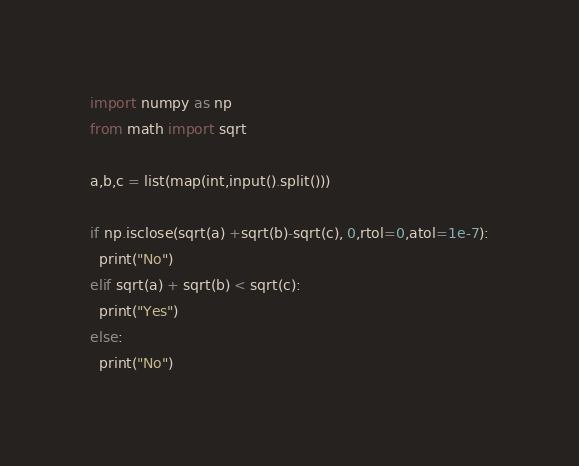Convert code to text. <code><loc_0><loc_0><loc_500><loc_500><_Python_>import numpy as np
from math import sqrt

a,b,c = list(map(int,input().split()))

if np.isclose(sqrt(a) +sqrt(b)-sqrt(c), 0,rtol=0,atol=1e-7):
  print("No")
elif sqrt(a) + sqrt(b) < sqrt(c):
  print("Yes")
else:
  print("No")
</code> 